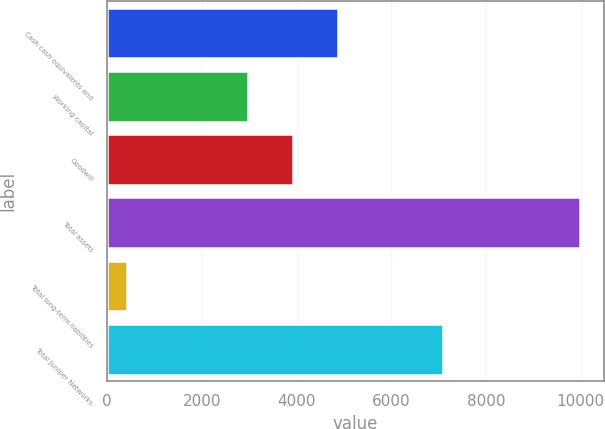Convert chart. <chart><loc_0><loc_0><loc_500><loc_500><bar_chart><fcel>Cash cash equivalents and<fcel>Working capital<fcel>Goodwill<fcel>Total assets<fcel>Total long-term liabilities<fcel>Total Juniper Networks<nl><fcel>4884.08<fcel>2973<fcel>3928.54<fcel>9983.8<fcel>428.4<fcel>7089.2<nl></chart> 